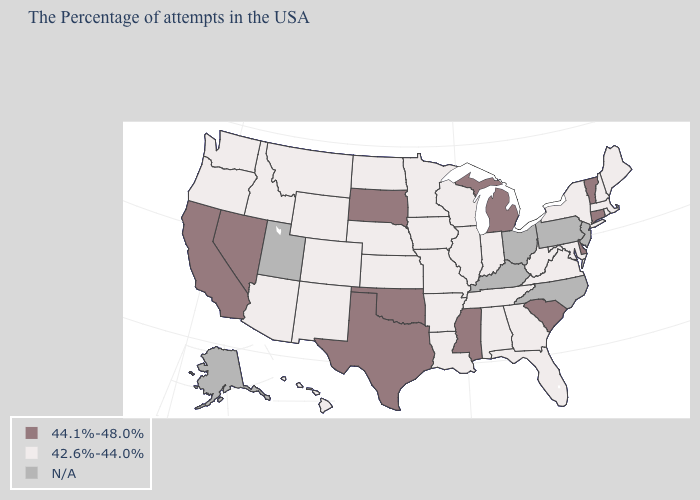What is the value of Texas?
Answer briefly. 44.1%-48.0%. Name the states that have a value in the range 44.1%-48.0%?
Answer briefly. Vermont, Connecticut, Delaware, South Carolina, Michigan, Mississippi, Oklahoma, Texas, South Dakota, Nevada, California. What is the value of Alaska?
Give a very brief answer. N/A. Does the first symbol in the legend represent the smallest category?
Give a very brief answer. No. Is the legend a continuous bar?
Answer briefly. No. What is the highest value in the USA?
Write a very short answer. 44.1%-48.0%. Does Washington have the lowest value in the USA?
Keep it brief. Yes. What is the value of Vermont?
Write a very short answer. 44.1%-48.0%. What is the value of Florida?
Be succinct. 42.6%-44.0%. Is the legend a continuous bar?
Quick response, please. No. Does Wisconsin have the highest value in the USA?
Be succinct. No. Is the legend a continuous bar?
Short answer required. No. Does the first symbol in the legend represent the smallest category?
Answer briefly. No. Does Nevada have the highest value in the USA?
Quick response, please. Yes. Among the states that border Illinois , which have the highest value?
Keep it brief. Indiana, Wisconsin, Missouri, Iowa. 